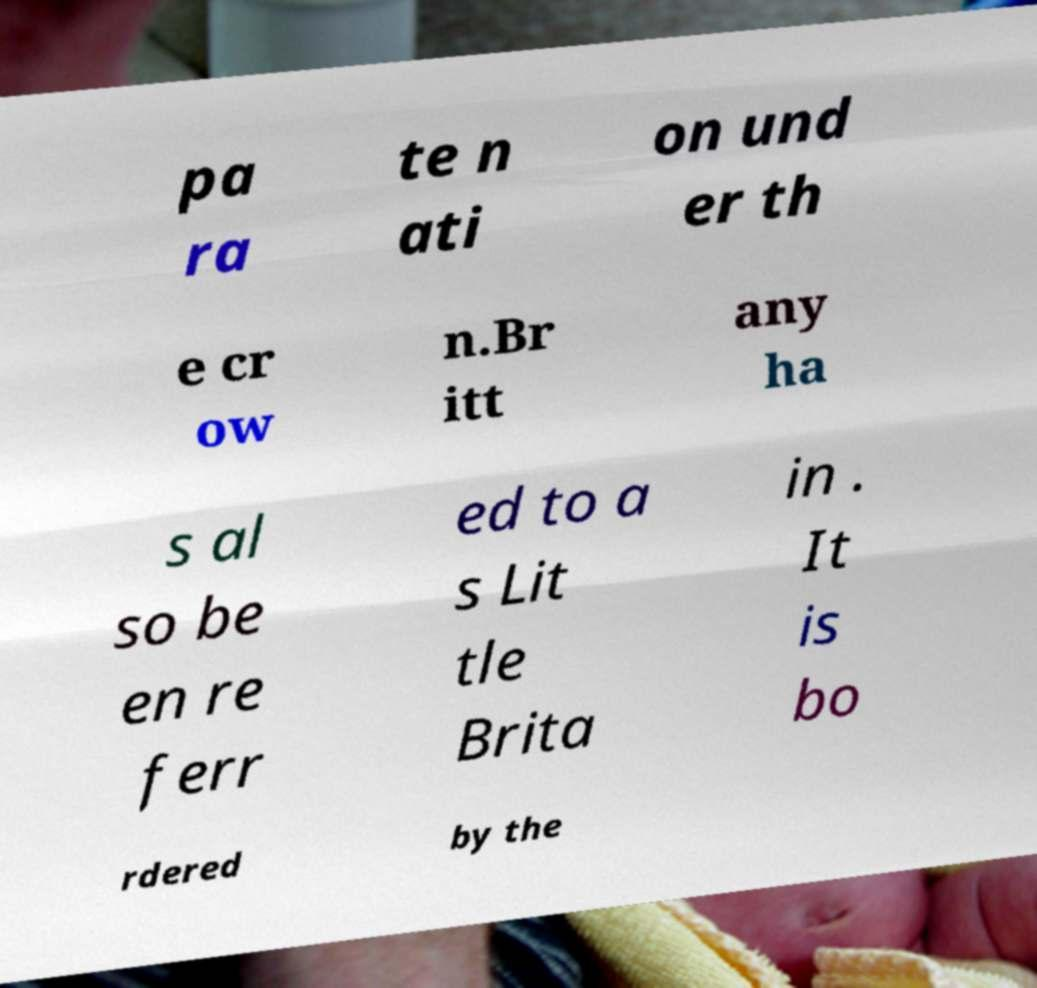For documentation purposes, I need the text within this image transcribed. Could you provide that? pa ra te n ati on und er th e cr ow n.Br itt any ha s al so be en re ferr ed to a s Lit tle Brita in . It is bo rdered by the 